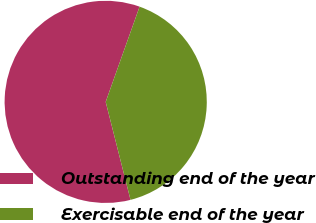Convert chart to OTSL. <chart><loc_0><loc_0><loc_500><loc_500><pie_chart><fcel>Outstanding end of the year<fcel>Exercisable end of the year<nl><fcel>59.39%<fcel>40.61%<nl></chart> 